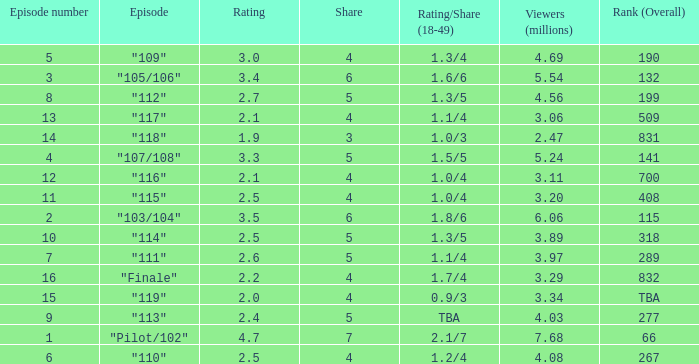WHAT IS THE HIGHEST VIEWERS WITH AN EPISODE LESS THAN 15 AND SHARE LAGER THAN 7? None. 